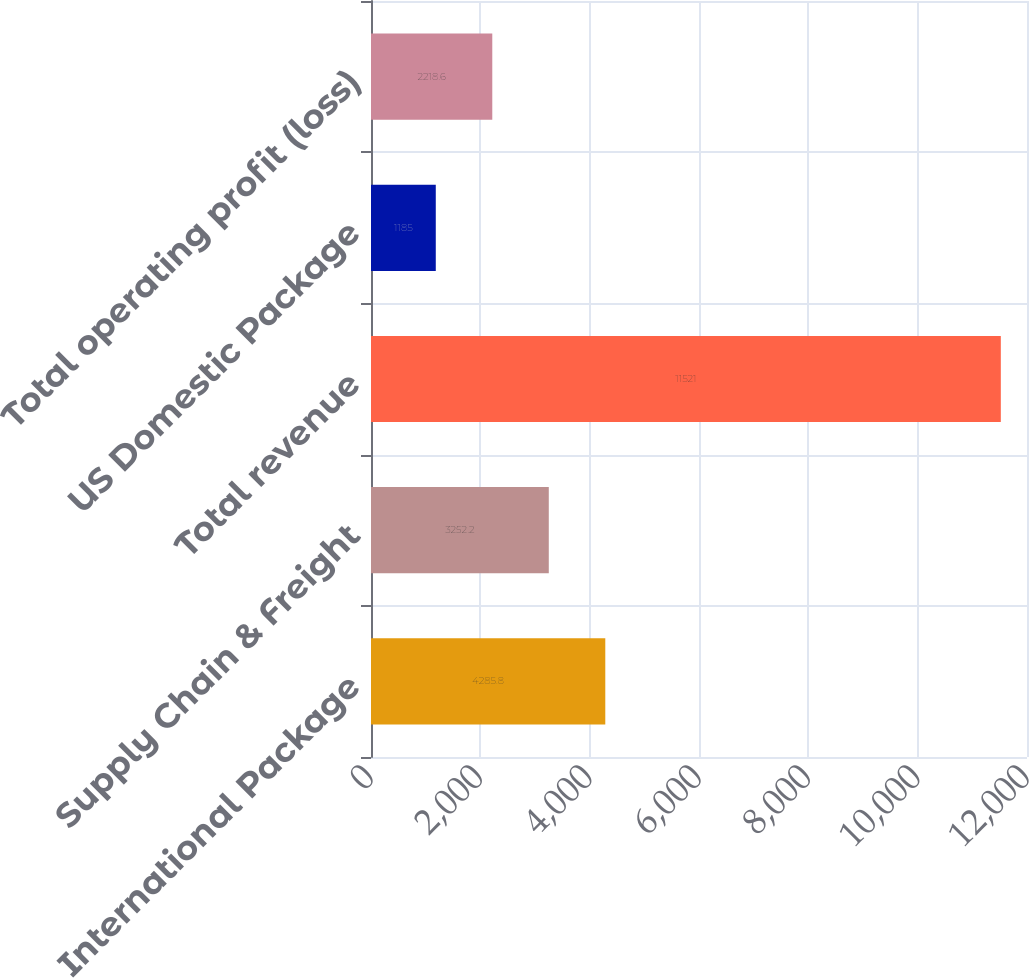<chart> <loc_0><loc_0><loc_500><loc_500><bar_chart><fcel>International Package<fcel>Supply Chain & Freight<fcel>Total revenue<fcel>US Domestic Package<fcel>Total operating profit (loss)<nl><fcel>4285.8<fcel>3252.2<fcel>11521<fcel>1185<fcel>2218.6<nl></chart> 